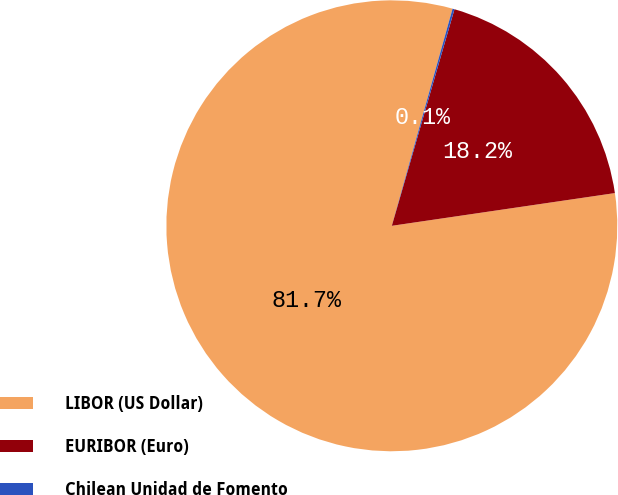Convert chart. <chart><loc_0><loc_0><loc_500><loc_500><pie_chart><fcel>LIBOR (US Dollar)<fcel>EURIBOR (Euro)<fcel>Chilean Unidad de Fomento<nl><fcel>81.66%<fcel>18.2%<fcel>0.14%<nl></chart> 